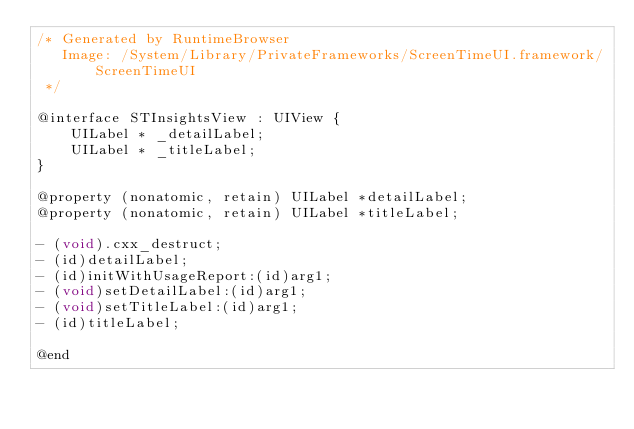<code> <loc_0><loc_0><loc_500><loc_500><_C_>/* Generated by RuntimeBrowser
   Image: /System/Library/PrivateFrameworks/ScreenTimeUI.framework/ScreenTimeUI
 */

@interface STInsightsView : UIView {
    UILabel * _detailLabel;
    UILabel * _titleLabel;
}

@property (nonatomic, retain) UILabel *detailLabel;
@property (nonatomic, retain) UILabel *titleLabel;

- (void).cxx_destruct;
- (id)detailLabel;
- (id)initWithUsageReport:(id)arg1;
- (void)setDetailLabel:(id)arg1;
- (void)setTitleLabel:(id)arg1;
- (id)titleLabel;

@end
</code> 